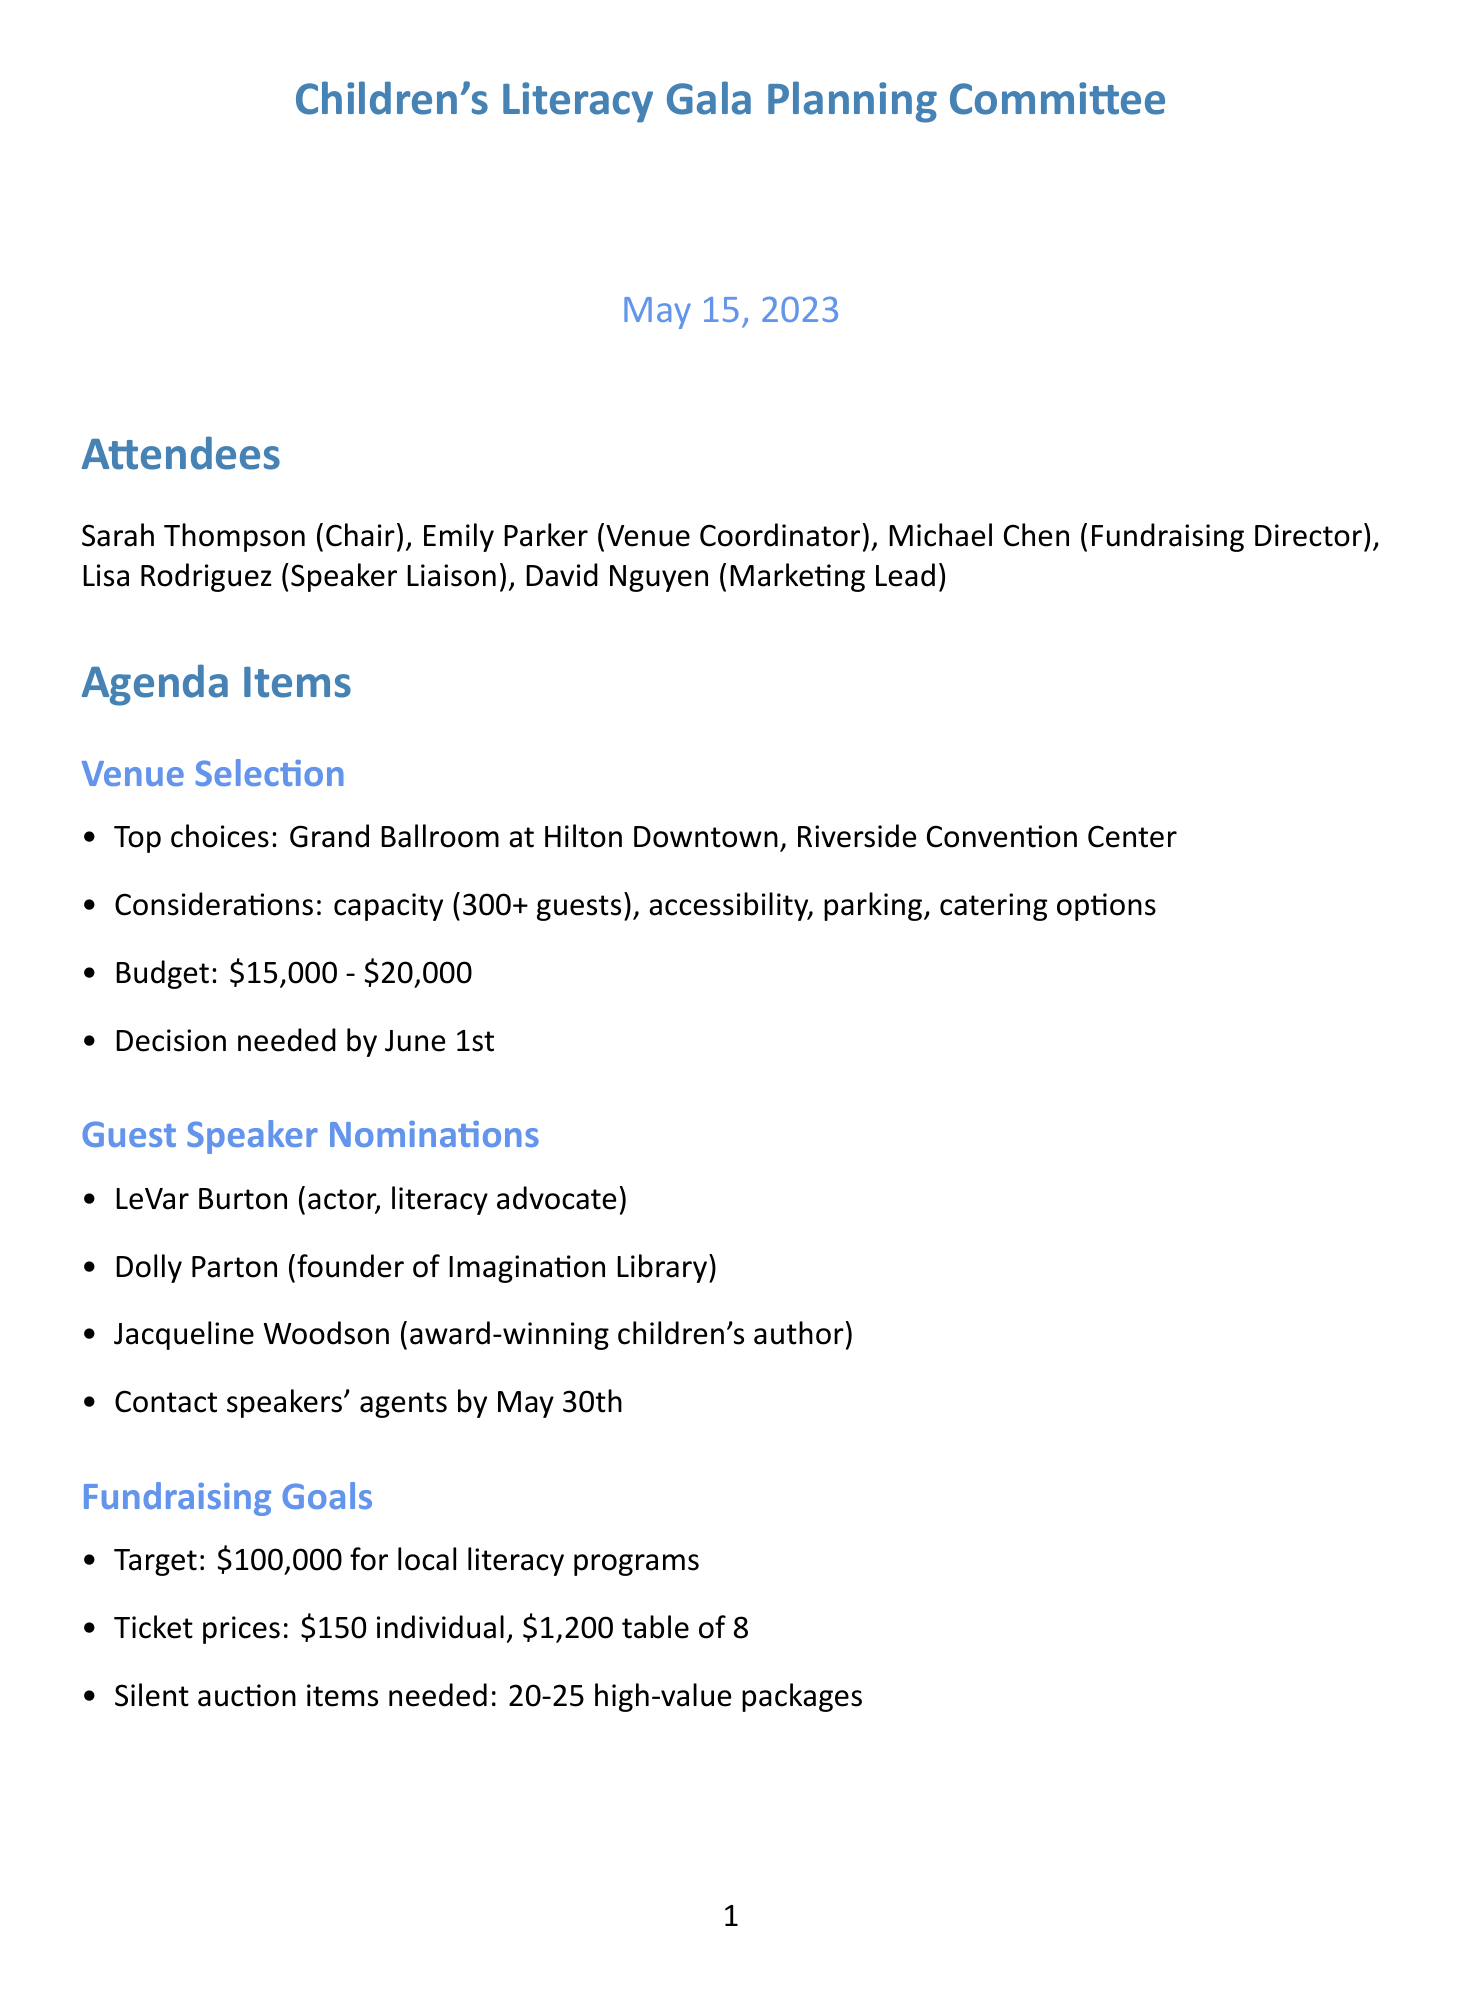What is the meeting date? The meeting date is found in the document header as the date of the meeting.
Answer: May 15, 2023 Who is the Chair of the committee? The Chair of the committee is listed among the attendees at the beginning of the document.
Answer: Sarah Thompson What is the venue selection budget range? The budget range is specifically mentioned in the details under the venue selection topic.
Answer: $15,000 - $20,000 What is the target amount for fundraising? The fundraising target is stated under the fundraising goals section.
Answer: $100,000 Who are the three guest speaker nominees? The guest speaker nominations include several names outlined in the agenda, of which three are specifically requested for the answer.
Answer: LeVar Burton, Dolly Parton, Jacqueline Woodson What is the proposed theme for the event? The proposed theme for the event is listed in the event theme section of the document.
Answer: 'Empowering Young Minds Through Literature' When is the next meeting scheduled? The next meeting is mentioned at the bottom of the document with the date and time clearly stated.
Answer: June 5, 2023 at 2:00 PM What action is Emily responsible for? The action items section lists Emily's specific responsibilities related to venue selection.
Answer: Schedule venue tours and prepare comparison report How many silent auction items are needed? The number of silent auction items required is provided in the fundraising goals section of the document.
Answer: 20-25 high-value packages 